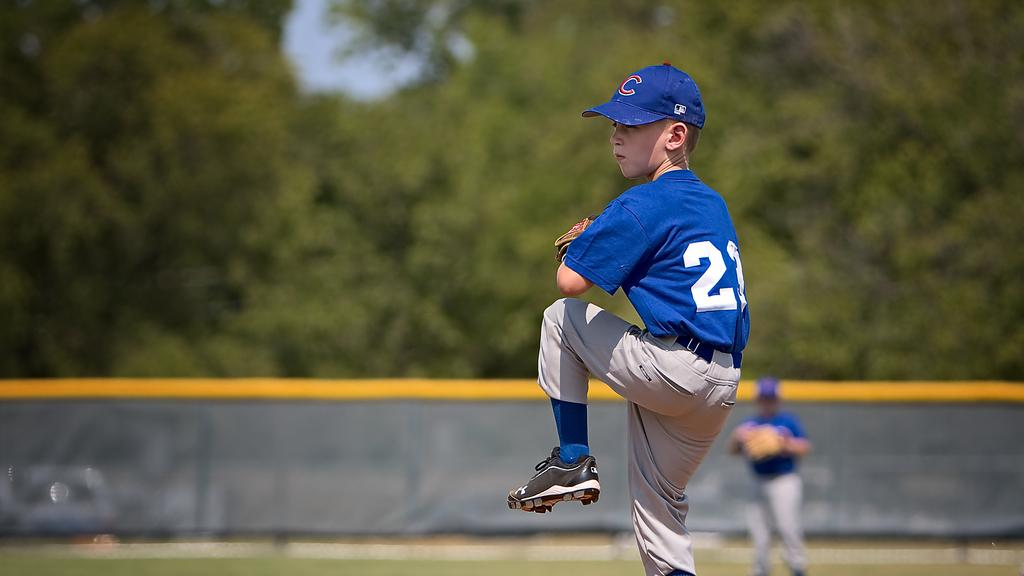<image>
Summarize the visual content of the image. A baseball pitcher in a blue shirt with a number 21. 